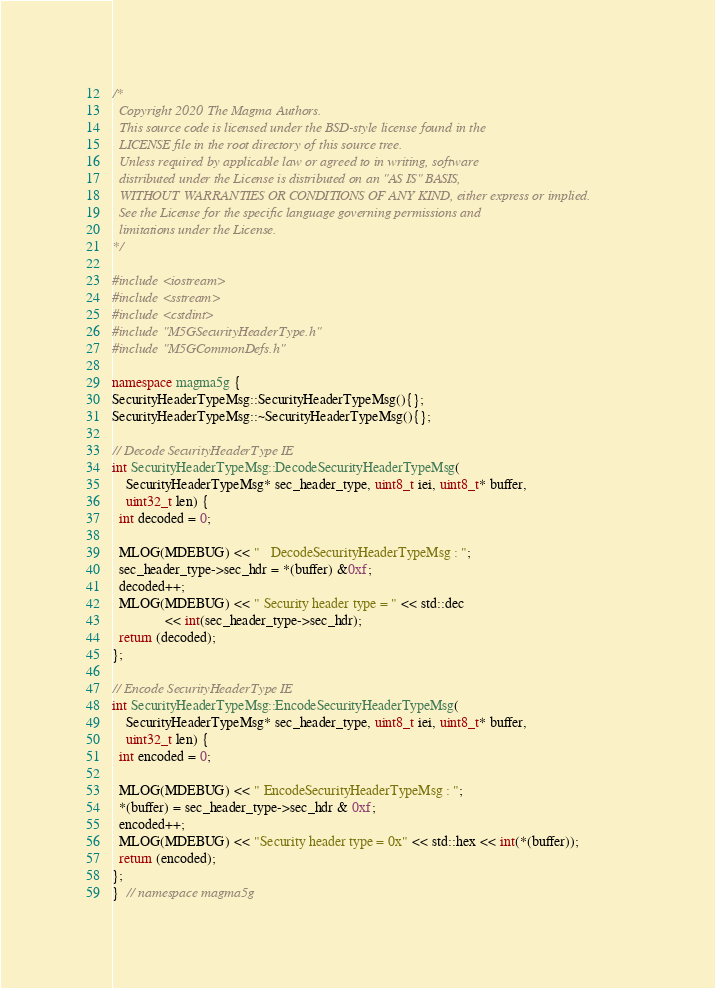<code> <loc_0><loc_0><loc_500><loc_500><_C++_>/*
  Copyright 2020 The Magma Authors.
  This source code is licensed under the BSD-style license found in the
  LICENSE file in the root directory of this source tree.
  Unless required by applicable law or agreed to in writing, software
  distributed under the License is distributed on an "AS IS" BASIS,
  WITHOUT WARRANTIES OR CONDITIONS OF ANY KIND, either express or implied.
  See the License for the specific language governing permissions and
  limitations under the License.
*/

#include <iostream>
#include <sstream>
#include <cstdint>
#include "M5GSecurityHeaderType.h"
#include "M5GCommonDefs.h"

namespace magma5g {
SecurityHeaderTypeMsg::SecurityHeaderTypeMsg(){};
SecurityHeaderTypeMsg::~SecurityHeaderTypeMsg(){};

// Decode SecurityHeaderType IE
int SecurityHeaderTypeMsg::DecodeSecurityHeaderTypeMsg(
    SecurityHeaderTypeMsg* sec_header_type, uint8_t iei, uint8_t* buffer,
    uint32_t len) {
  int decoded = 0;

  MLOG(MDEBUG) << "   DecodeSecurityHeaderTypeMsg : ";
  sec_header_type->sec_hdr = *(buffer) &0xf;
  decoded++;
  MLOG(MDEBUG) << " Security header type = " << std::dec
               << int(sec_header_type->sec_hdr);
  return (decoded);
};

// Encode SecurityHeaderType IE
int SecurityHeaderTypeMsg::EncodeSecurityHeaderTypeMsg(
    SecurityHeaderTypeMsg* sec_header_type, uint8_t iei, uint8_t* buffer,
    uint32_t len) {
  int encoded = 0;

  MLOG(MDEBUG) << " EncodeSecurityHeaderTypeMsg : ";
  *(buffer) = sec_header_type->sec_hdr & 0xf;
  encoded++;
  MLOG(MDEBUG) << "Security header type = 0x" << std::hex << int(*(buffer));
  return (encoded);
};
}  // namespace magma5g
</code> 